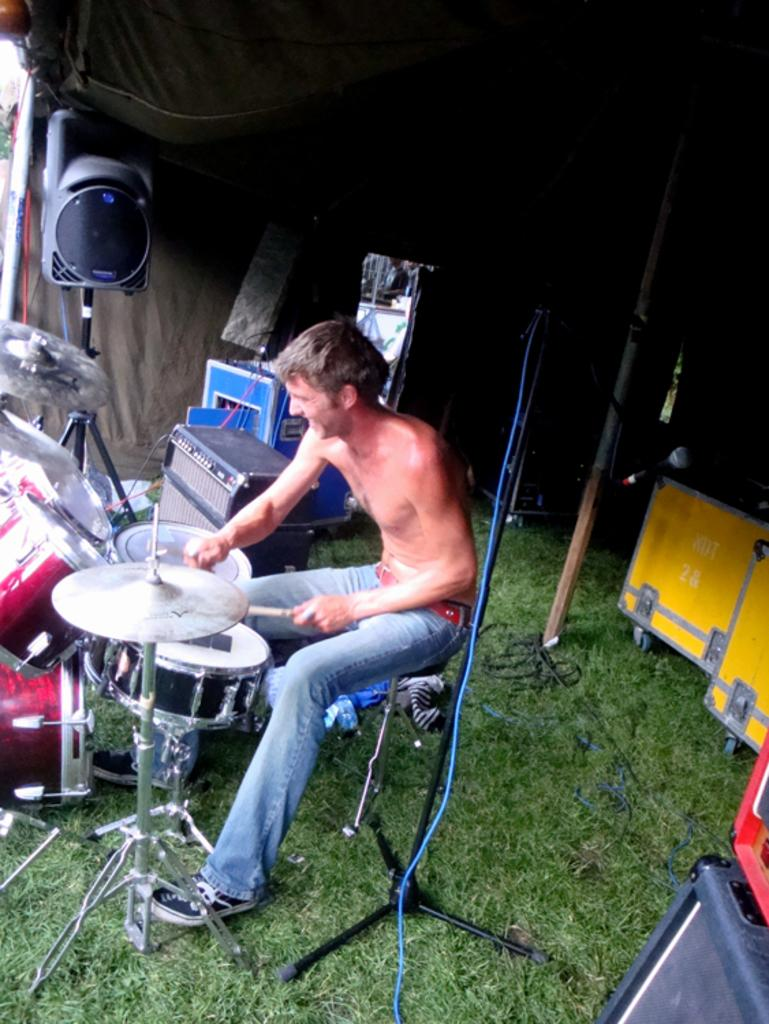What is the main subject of the image? There is a man sitting in the center of the image. What is the man doing in the image? The man is playing a band in the image. What can be seen behind the man? There is a stand behind the man. What type of equipment is present in the image? There is a speaker in the image. What type of environment is depicted in the image? There is a tent at the top of the image and grass at the bottom of the image. What direction is the smell of the grass coming from in the image? The image does not convey any information about smells, so it is not possible to determine the direction of the smell of the grass. 